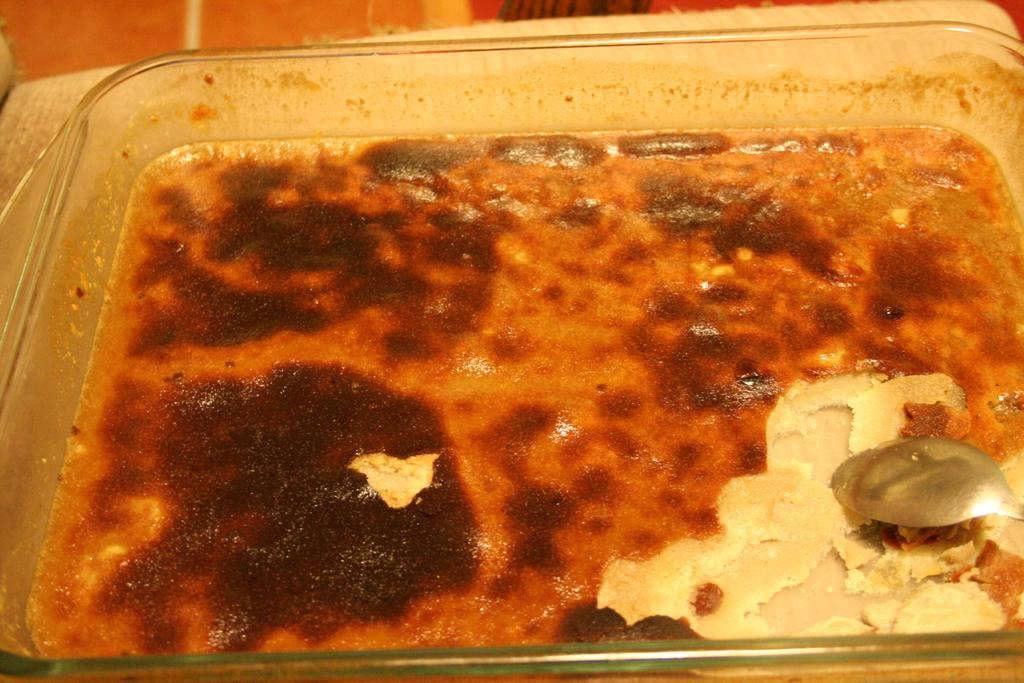What is on the table in the image? There is a bowl on the table in the image. What is inside the bowl? The bowl contains cake. What utensil is in the bowl? There is a spoon in the bowl. What is on the left side of the table? There is a mat on the left side of the table. Can you see any geese swimming in the river in the image? There is no river or geese present in the image. 